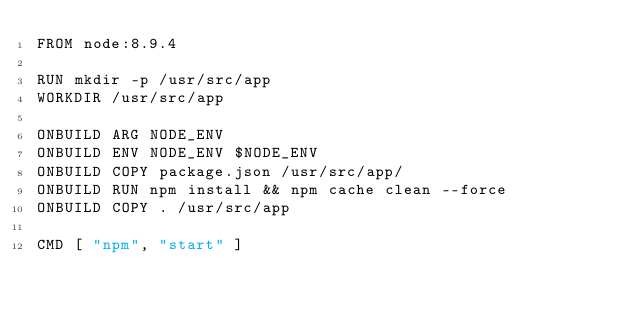<code> <loc_0><loc_0><loc_500><loc_500><_Dockerfile_>FROM node:8.9.4

RUN mkdir -p /usr/src/app
WORKDIR /usr/src/app

ONBUILD ARG NODE_ENV
ONBUILD ENV NODE_ENV $NODE_ENV
ONBUILD COPY package.json /usr/src/app/
ONBUILD RUN npm install && npm cache clean --force
ONBUILD COPY . /usr/src/app

CMD [ "npm", "start" ]
</code> 